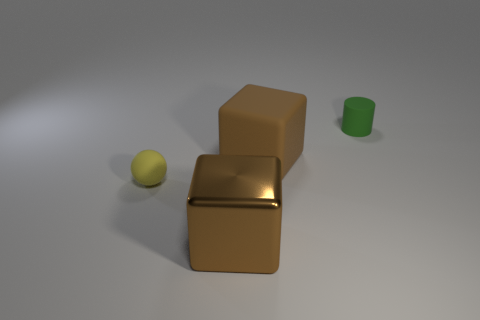What is the size of the brown block that is the same material as the tiny yellow sphere?
Provide a short and direct response. Large. Is there a small red shiny cube?
Provide a short and direct response. No. Does the metallic object have the same color as the large matte block?
Offer a terse response. Yes. What number of large objects are brown rubber things or green cylinders?
Offer a very short reply. 1. Is there any other thing that has the same color as the cylinder?
Offer a terse response. No. There is a yellow object that is made of the same material as the green cylinder; what is its shape?
Ensure brevity in your answer.  Sphere. How big is the green matte thing that is on the right side of the tiny yellow thing?
Keep it short and to the point. Small. What shape is the big brown rubber object?
Offer a terse response. Cube. There is a brown cube that is behind the small yellow sphere; is its size the same as the shiny object to the right of the tiny yellow rubber object?
Your answer should be very brief. Yes. There is a brown thing behind the small matte object that is left of the small thing behind the small yellow matte object; how big is it?
Give a very brief answer. Large. 